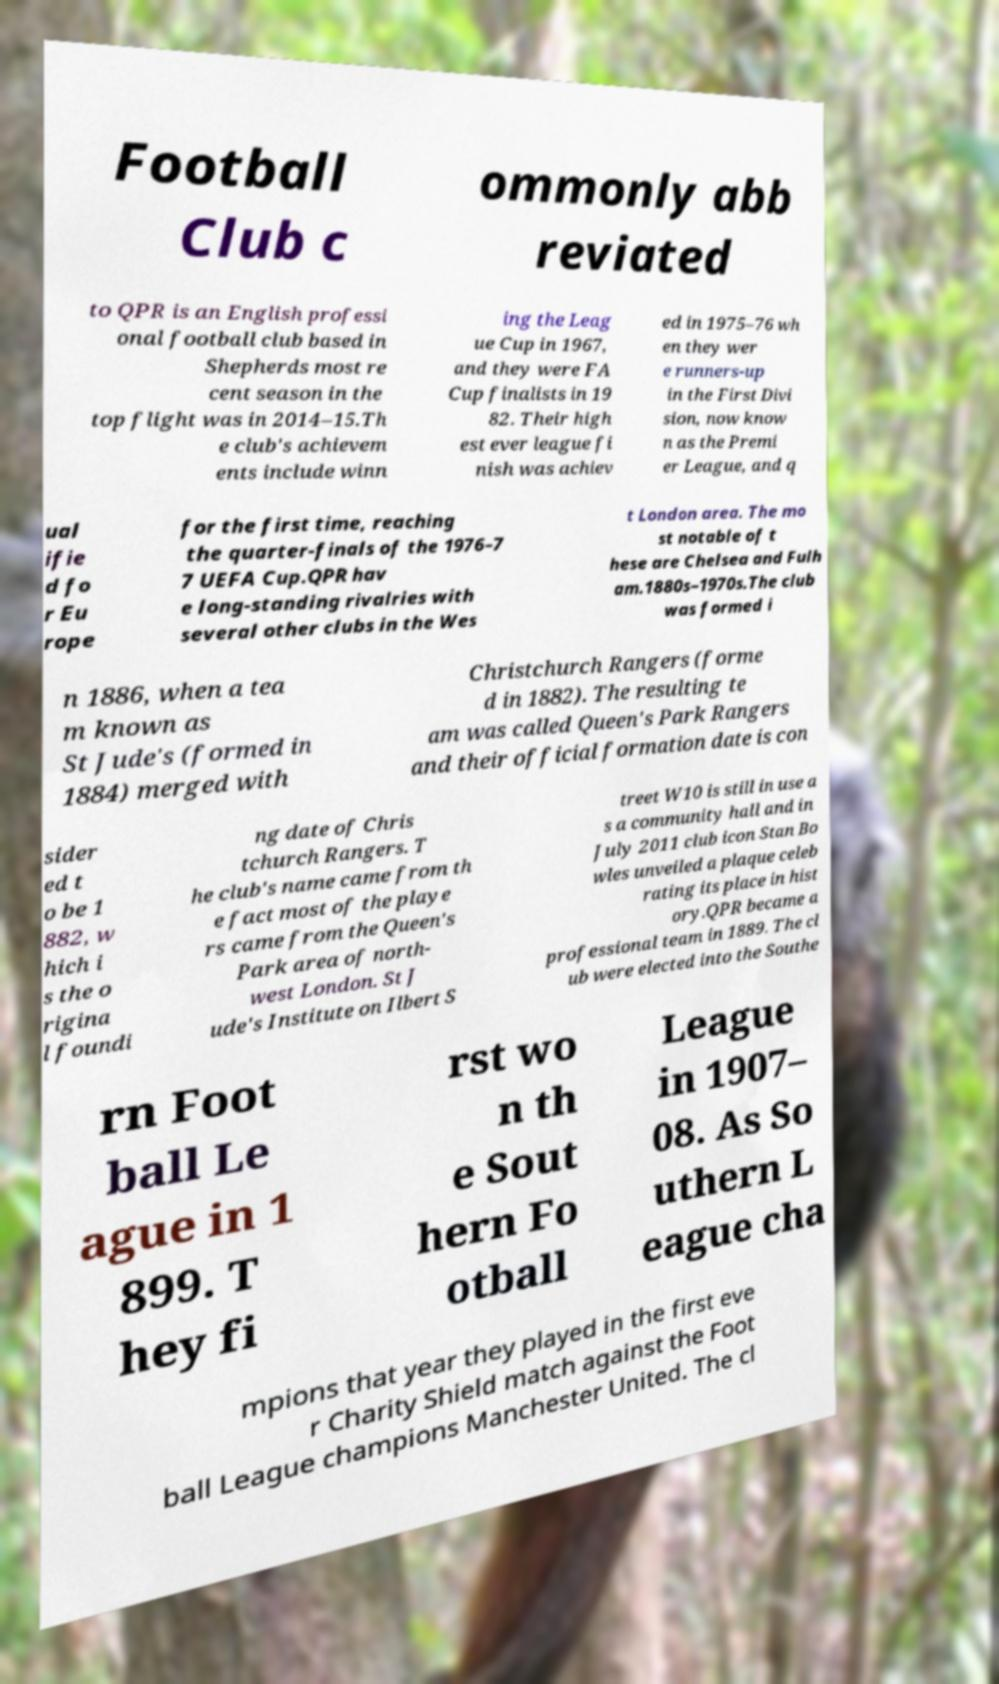Could you assist in decoding the text presented in this image and type it out clearly? Football Club c ommonly abb reviated to QPR is an English professi onal football club based in Shepherds most re cent season in the top flight was in 2014–15.Th e club's achievem ents include winn ing the Leag ue Cup in 1967, and they were FA Cup finalists in 19 82. Their high est ever league fi nish was achiev ed in 1975–76 wh en they wer e runners-up in the First Divi sion, now know n as the Premi er League, and q ual ifie d fo r Eu rope for the first time, reaching the quarter-finals of the 1976–7 7 UEFA Cup.QPR hav e long-standing rivalries with several other clubs in the Wes t London area. The mo st notable of t hese are Chelsea and Fulh am.1880s–1970s.The club was formed i n 1886, when a tea m known as St Jude's (formed in 1884) merged with Christchurch Rangers (forme d in 1882). The resulting te am was called Queen's Park Rangers and their official formation date is con sider ed t o be 1 882, w hich i s the o rigina l foundi ng date of Chris tchurch Rangers. T he club's name came from th e fact most of the playe rs came from the Queen's Park area of north- west London. St J ude's Institute on Ilbert S treet W10 is still in use a s a community hall and in July 2011 club icon Stan Bo wles unveiled a plaque celeb rating its place in hist ory.QPR became a professional team in 1889. The cl ub were elected into the Southe rn Foot ball Le ague in 1 899. T hey fi rst wo n th e Sout hern Fo otball League in 1907– 08. As So uthern L eague cha mpions that year they played in the first eve r Charity Shield match against the Foot ball League champions Manchester United. The cl 